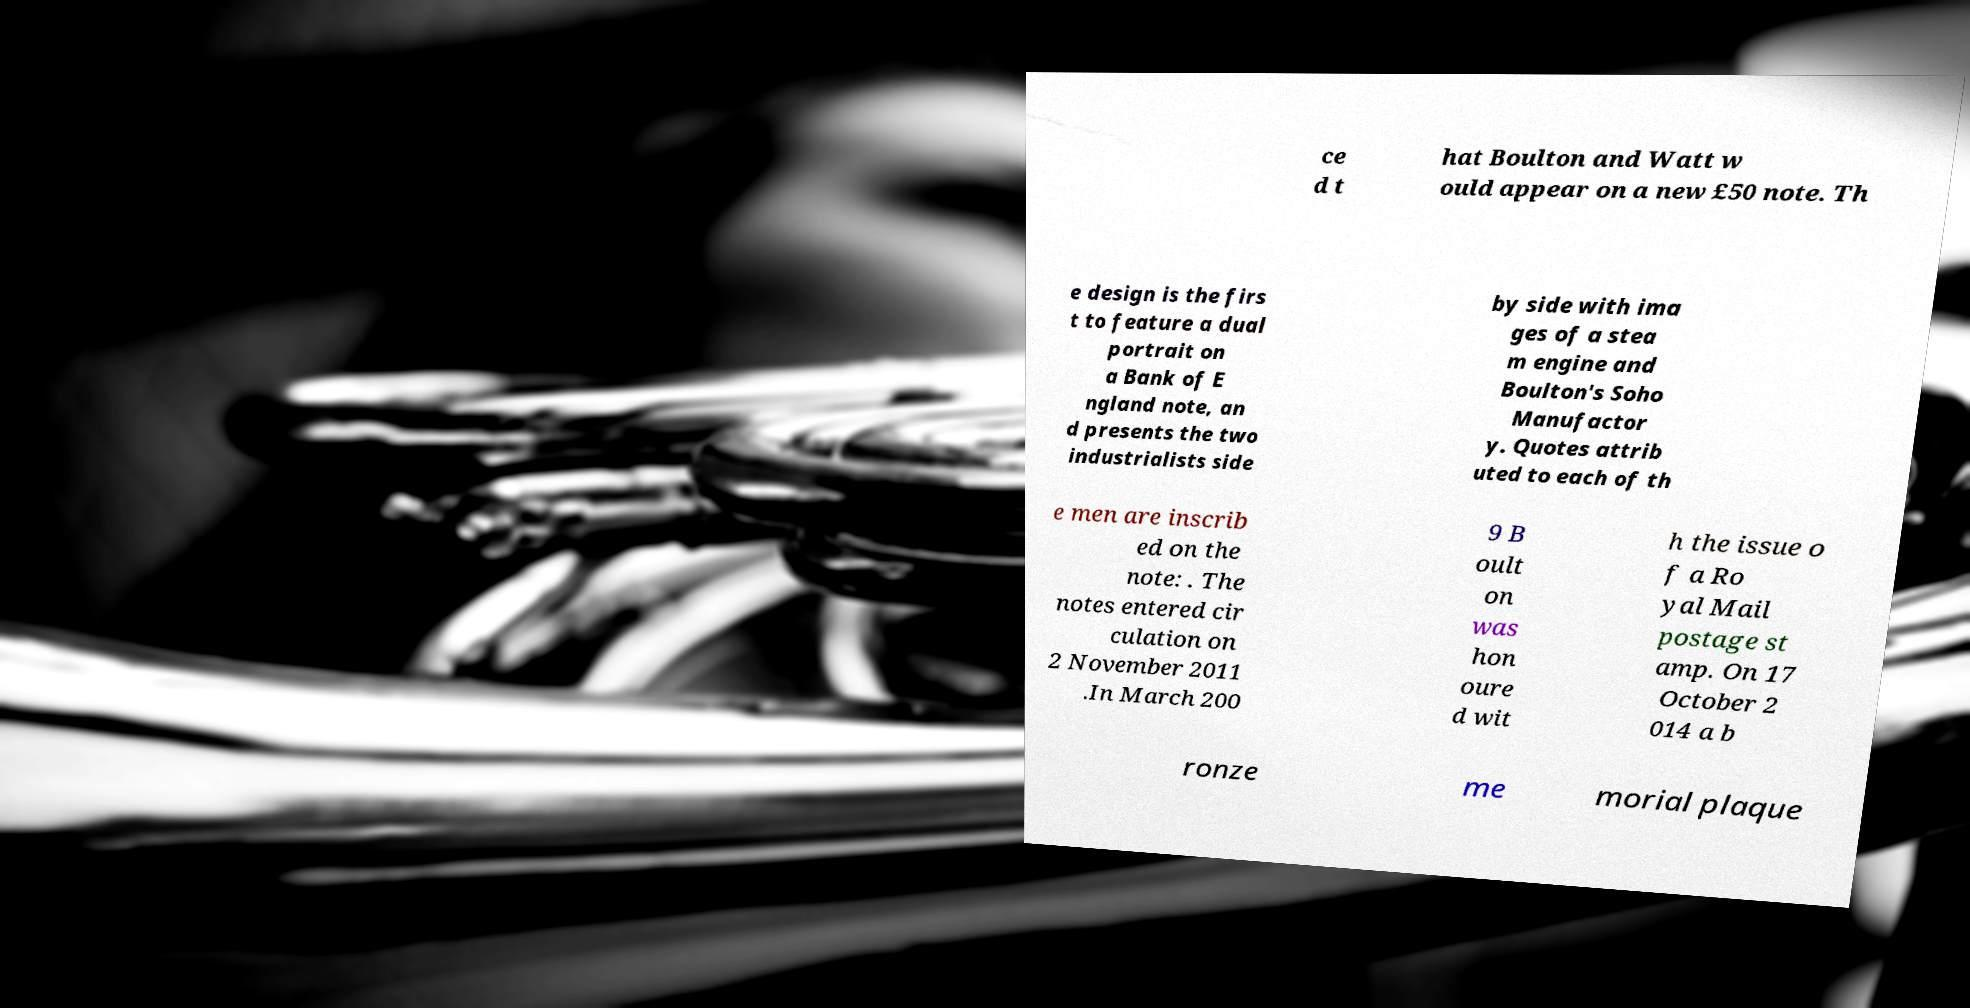There's text embedded in this image that I need extracted. Can you transcribe it verbatim? ce d t hat Boulton and Watt w ould appear on a new £50 note. Th e design is the firs t to feature a dual portrait on a Bank of E ngland note, an d presents the two industrialists side by side with ima ges of a stea m engine and Boulton's Soho Manufactor y. Quotes attrib uted to each of th e men are inscrib ed on the note: . The notes entered cir culation on 2 November 2011 .In March 200 9 B oult on was hon oure d wit h the issue o f a Ro yal Mail postage st amp. On 17 October 2 014 a b ronze me morial plaque 